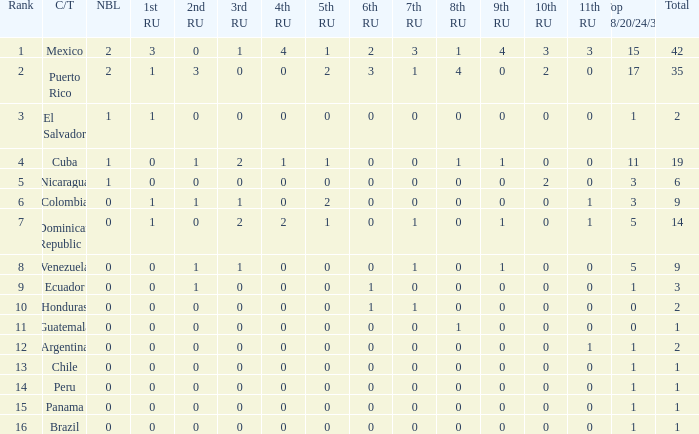What is the total number of 3rd runners-up of the country ranked lower than 12 with a 10th runner-up of 0, an 8th runner-up less than 1, and a 7th runner-up of 0? 4.0. Give me the full table as a dictionary. {'header': ['Rank', 'C/T', 'NBL', '1st RU', '2nd RU', '3rd RU', '4th RU', '5th RU', '6th RU', '7th RU', '8th RU', '9th RU', '10th RU', '11th RU', 'Top 18/20/24/30', 'Total'], 'rows': [['1', 'Mexico', '2', '3', '0', '1', '4', '1', '2', '3', '1', '4', '3', '3', '15', '42'], ['2', 'Puerto Rico', '2', '1', '3', '0', '0', '2', '3', '1', '4', '0', '2', '0', '17', '35'], ['3', 'El Salvador', '1', '1', '0', '0', '0', '0', '0', '0', '0', '0', '0', '0', '1', '2'], ['4', 'Cuba', '1', '0', '1', '2', '1', '1', '0', '0', '1', '1', '0', '0', '11', '19'], ['5', 'Nicaragua', '1', '0', '0', '0', '0', '0', '0', '0', '0', '0', '2', '0', '3', '6'], ['6', 'Colombia', '0', '1', '1', '1', '0', '2', '0', '0', '0', '0', '0', '1', '3', '9'], ['7', 'Dominican Republic', '0', '1', '0', '2', '2', '1', '0', '1', '0', '1', '0', '1', '5', '14'], ['8', 'Venezuela', '0', '0', '1', '1', '0', '0', '0', '1', '0', '1', '0', '0', '5', '9'], ['9', 'Ecuador', '0', '0', '1', '0', '0', '0', '1', '0', '0', '0', '0', '0', '1', '3'], ['10', 'Honduras', '0', '0', '0', '0', '0', '0', '1', '1', '0', '0', '0', '0', '0', '2'], ['11', 'Guatemala', '0', '0', '0', '0', '0', '0', '0', '0', '1', '0', '0', '0', '0', '1'], ['12', 'Argentina', '0', '0', '0', '0', '0', '0', '0', '0', '0', '0', '0', '1', '1', '2'], ['13', 'Chile', '0', '0', '0', '0', '0', '0', '0', '0', '0', '0', '0', '0', '1', '1'], ['14', 'Peru', '0', '0', '0', '0', '0', '0', '0', '0', '0', '0', '0', '0', '1', '1'], ['15', 'Panama', '0', '0', '0', '0', '0', '0', '0', '0', '0', '0', '0', '0', '1', '1'], ['16', 'Brazil', '0', '0', '0', '0', '0', '0', '0', '0', '0', '0', '0', '0', '1', '1']]} 